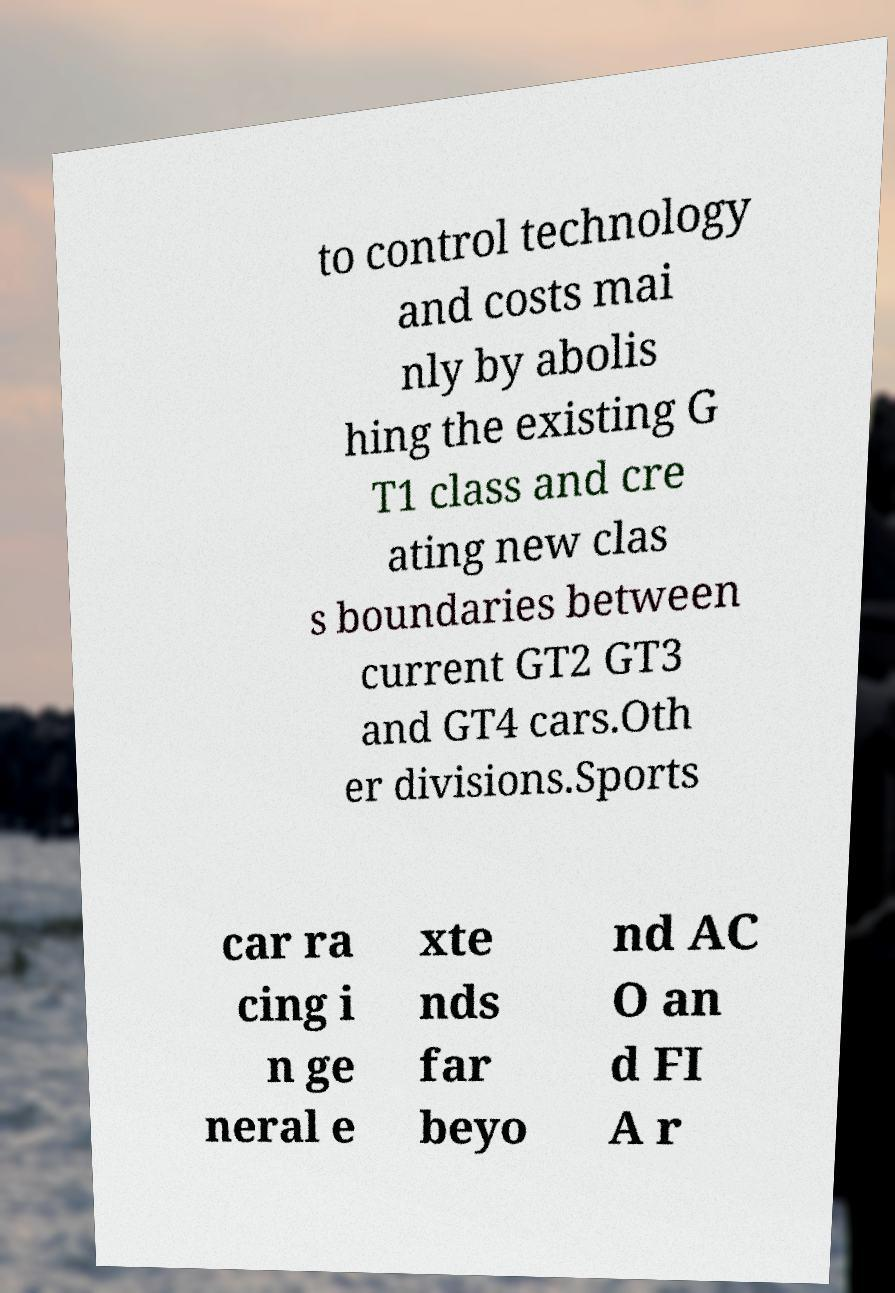Please identify and transcribe the text found in this image. to control technology and costs mai nly by abolis hing the existing G T1 class and cre ating new clas s boundaries between current GT2 GT3 and GT4 cars.Oth er divisions.Sports car ra cing i n ge neral e xte nds far beyo nd AC O an d FI A r 